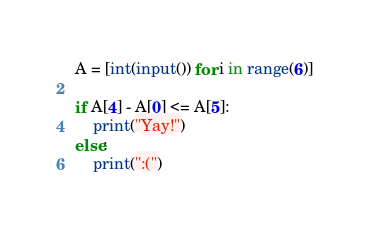<code> <loc_0><loc_0><loc_500><loc_500><_Python_>A = [int(input()) for i in range(6)]

if A[4] - A[0] <= A[5]:
    print("Yay!")
else:
    print(":(")</code> 